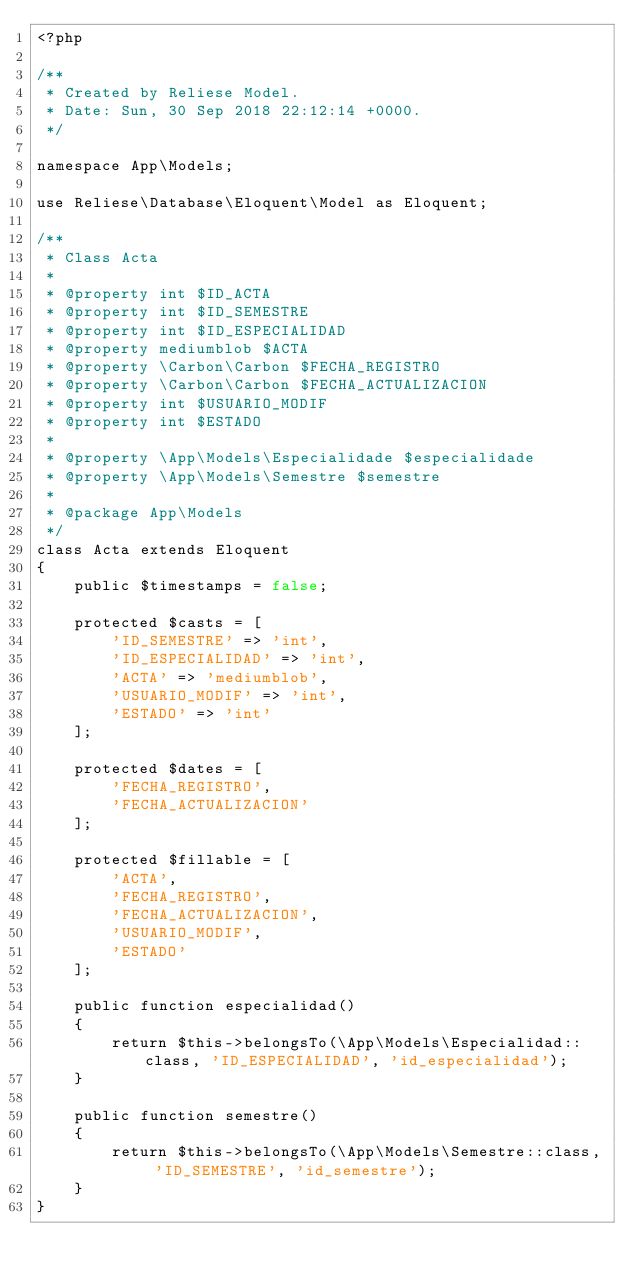<code> <loc_0><loc_0><loc_500><loc_500><_PHP_><?php

/**
 * Created by Reliese Model.
 * Date: Sun, 30 Sep 2018 22:12:14 +0000.
 */

namespace App\Models;

use Reliese\Database\Eloquent\Model as Eloquent;

/**
 * Class Acta
 * 
 * @property int $ID_ACTA
 * @property int $ID_SEMESTRE
 * @property int $ID_ESPECIALIDAD
 * @property mediumblob $ACTA
 * @property \Carbon\Carbon $FECHA_REGISTRO
 * @property \Carbon\Carbon $FECHA_ACTUALIZACION
 * @property int $USUARIO_MODIF
 * @property int $ESTADO
 * 
 * @property \App\Models\Especialidade $especialidade
 * @property \App\Models\Semestre $semestre
 *
 * @package App\Models
 */
class Acta extends Eloquent
{
	public $timestamps = false;

	protected $casts = [
		'ID_SEMESTRE' => 'int',
		'ID_ESPECIALIDAD' => 'int',
		'ACTA' => 'mediumblob',
		'USUARIO_MODIF' => 'int',
		'ESTADO' => 'int'
	];

	protected $dates = [
		'FECHA_REGISTRO',
		'FECHA_ACTUALIZACION'
	];

	protected $fillable = [
		'ACTA',
		'FECHA_REGISTRO',
		'FECHA_ACTUALIZACION',
		'USUARIO_MODIF',
		'ESTADO'
	];

	public function especialidad()
	{
		return $this->belongsTo(\App\Models\Especialidad::class, 'ID_ESPECIALIDAD', 'id_especialidad');
	}

	public function semestre()
	{
		return $this->belongsTo(\App\Models\Semestre::class, 'ID_SEMESTRE', 'id_semestre');
	}
}
</code> 